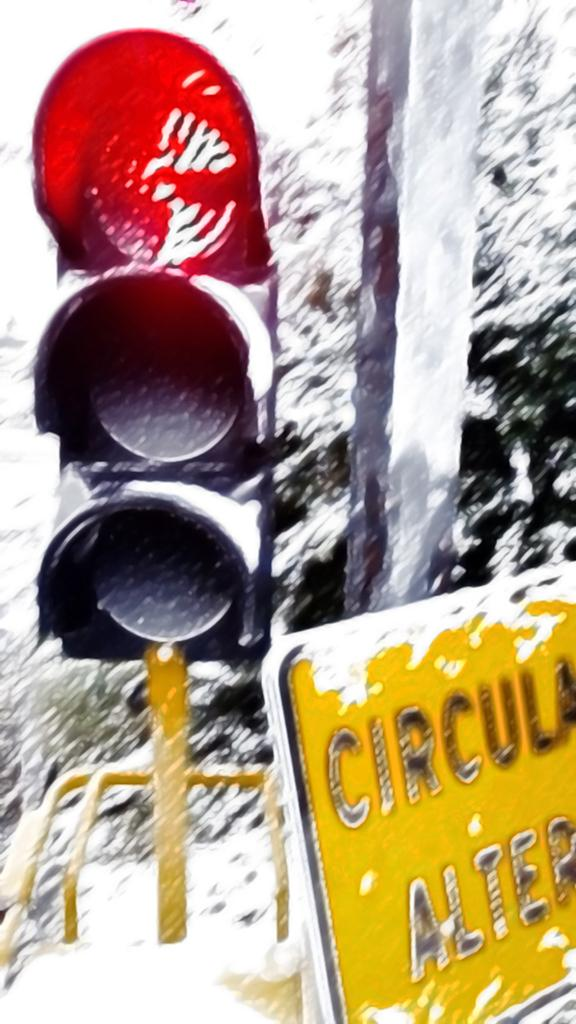Provide a one-sentence caption for the provided image. a stop sign in the snow with a yellow sign nearby that says circula on it. 